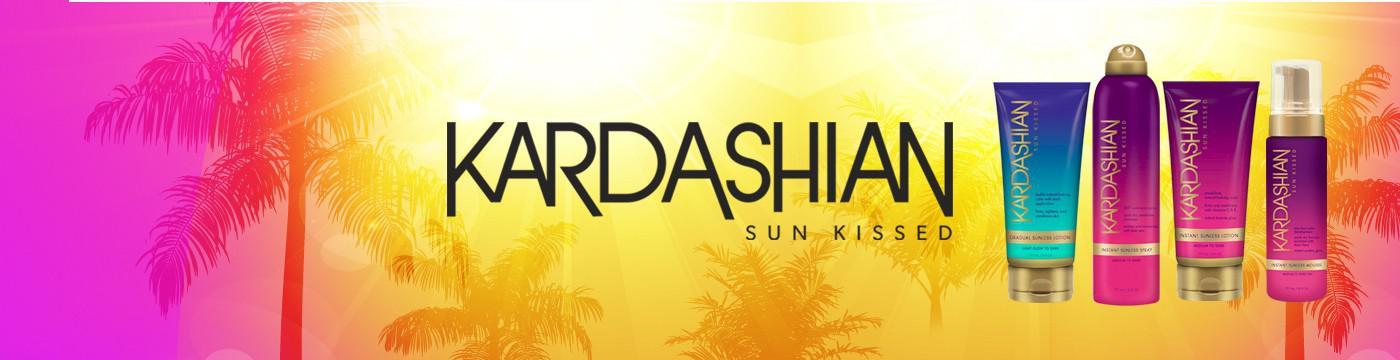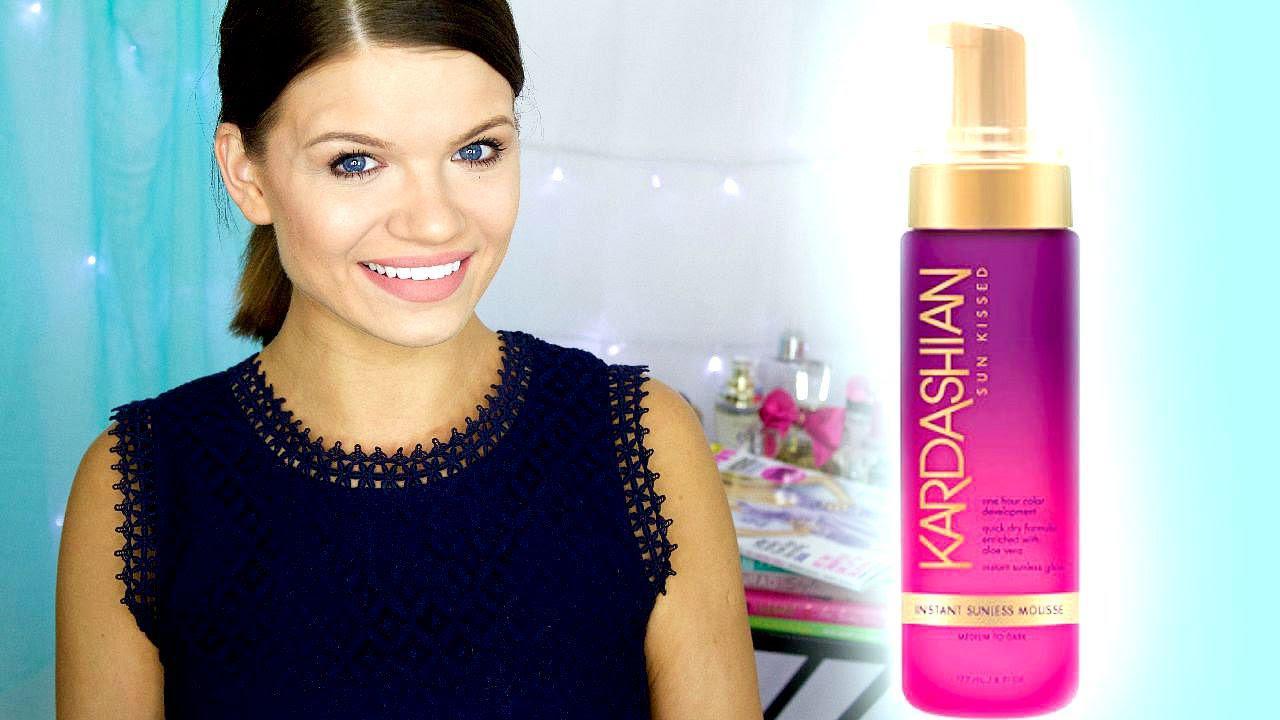The first image is the image on the left, the second image is the image on the right. Examine the images to the left and right. Is the description "There are a total of 5 brightly colored self-tanning accessories laying in the sand." accurate? Answer yes or no. No. The first image is the image on the left, the second image is the image on the right. For the images shown, is this caption "bottles of lotion are displayed on a sandy surface" true? Answer yes or no. No. 